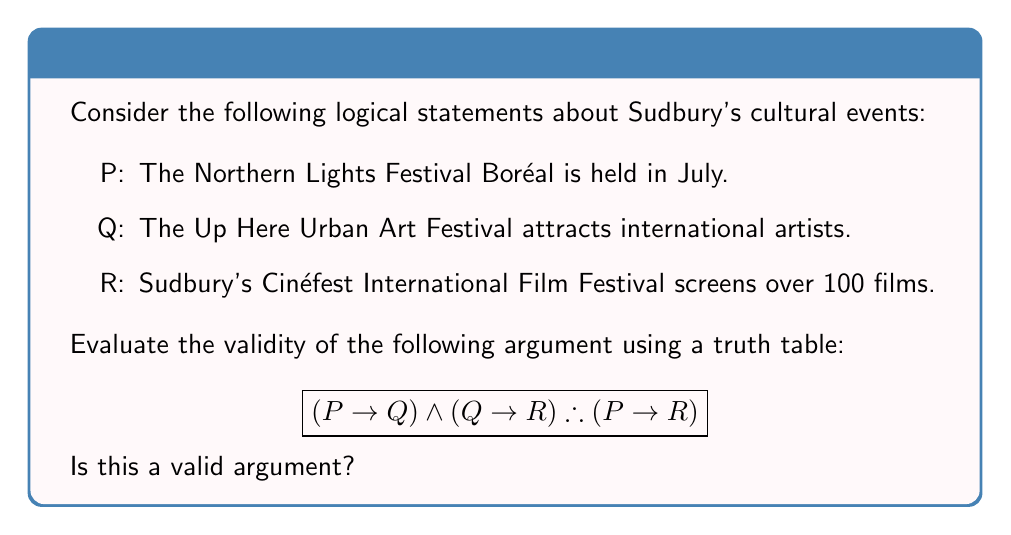Help me with this question. To determine the validity of this argument, we need to construct a truth table and examine if the conclusion $(P \rightarrow R)$ is true whenever all the premises are true.

Step 1: Construct the truth table with columns for P, Q, R, and the premises $(P \rightarrow Q)$ and $(Q \rightarrow R)$.

$$\begin{array}{|c|c|c|c|c|c|}
\hline
P & Q & R & (P \rightarrow Q) & (Q \rightarrow R) & (P \rightarrow Q) \land (Q \rightarrow R) \\
\hline
T & T & T & T & T & T \\
T & T & F & T & F & F \\
T & F & T & F & T & F \\
T & F & F & F & T & F \\
F & T & T & T & T & T \\
F & T & F & T & F & F \\
F & F & T & T & T & T \\
F & F & F & T & T & T \\
\hline
\end{array}$$

Step 2: Add a column for the conclusion $(P \rightarrow R)$.

$$\begin{array}{|c|c|c|c|c|c|c|}
\hline
P & Q & R & (P \rightarrow Q) & (Q \rightarrow R) & (P \rightarrow Q) \land (Q \rightarrow R) & (P \rightarrow R) \\
\hline
T & T & T & T & T & T & T \\
T & T & F & T & F & F & F \\
T & F & T & F & T & F & T \\
T & F & F & F & T & F & F \\
F & T & T & T & T & T & T \\
F & T & F & T & F & F & T \\
F & F & T & T & T & T & T \\
F & F & F & T & T & T & T \\
\hline
\end{array}$$

Step 3: Analyze the truth table. For the argument to be valid, whenever the premises $(P \rightarrow Q) \land (Q \rightarrow R)$ are true, the conclusion $(P \rightarrow R)$ must also be true.

We can see that there are four rows where the premises are true (rows 1, 5, 7, and 8). In all of these rows, the conclusion $(P \rightarrow R)$ is also true.

Therefore, this argument is valid. Whenever the premises are true, the conclusion is guaranteed to be true, regardless of the specific truth values of P, Q, and R.
Answer: Valid argument 